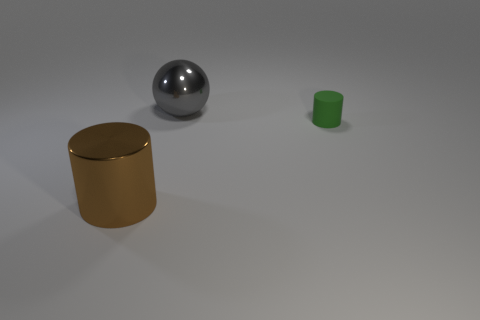Is there any other thing that has the same size as the green matte cylinder?
Your response must be concise. No. Are there an equal number of green things that are behind the ball and large gray spheres?
Give a very brief answer. No. Are there any brown metal cylinders that are left of the metallic object to the right of the large cylinder?
Your response must be concise. Yes. There is a rubber thing that is in front of the shiny thing to the right of the big shiny thing that is in front of the metallic sphere; how big is it?
Your answer should be compact. Small. What material is the big thing to the right of the metal object in front of the metal ball?
Give a very brief answer. Metal. Are there any other small green matte things of the same shape as the small green rubber object?
Offer a terse response. No. The big gray thing is what shape?
Your answer should be very brief. Sphere. What is the large thing in front of the cylinder on the right side of the metallic object in front of the small green thing made of?
Offer a terse response. Metal. Is the number of cylinders that are left of the small green matte cylinder greater than the number of blue metallic objects?
Ensure brevity in your answer.  Yes. There is another object that is the same size as the brown object; what is its material?
Your answer should be compact. Metal. 